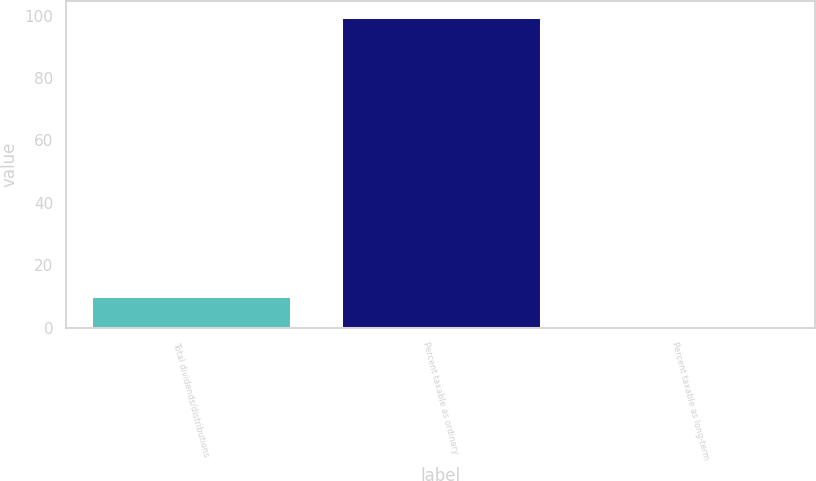<chart> <loc_0><loc_0><loc_500><loc_500><bar_chart><fcel>Total dividends/distributions<fcel>Percent taxable as ordinary<fcel>Percent taxable as long-term<nl><fcel>10.24<fcel>99.7<fcel>0.3<nl></chart> 